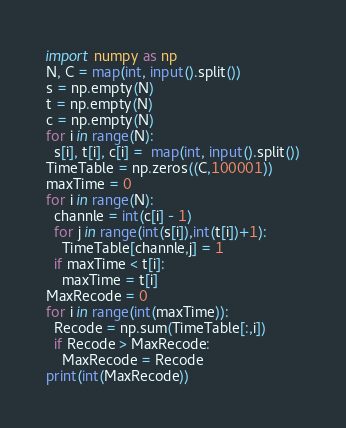Convert code to text. <code><loc_0><loc_0><loc_500><loc_500><_Python_>import numpy as np
N, C = map(int, input().split())
s = np.empty(N)
t = np.empty(N)
c = np.empty(N)
for i in range(N):
  s[i], t[i], c[i] =  map(int, input().split())
TimeTable = np.zeros((C,100001))
maxTime = 0
for i in range(N):
  channle = int(c[i] - 1)
  for j in range(int(s[i]),int(t[i])+1):
    TimeTable[channle,j] = 1
  if maxTime < t[i]:
    maxTime = t[i]
MaxRecode = 0
for i in range(int(maxTime)):
  Recode = np.sum(TimeTable[:,i])
  if Recode > MaxRecode:
    MaxRecode = Recode
print(int(MaxRecode))</code> 